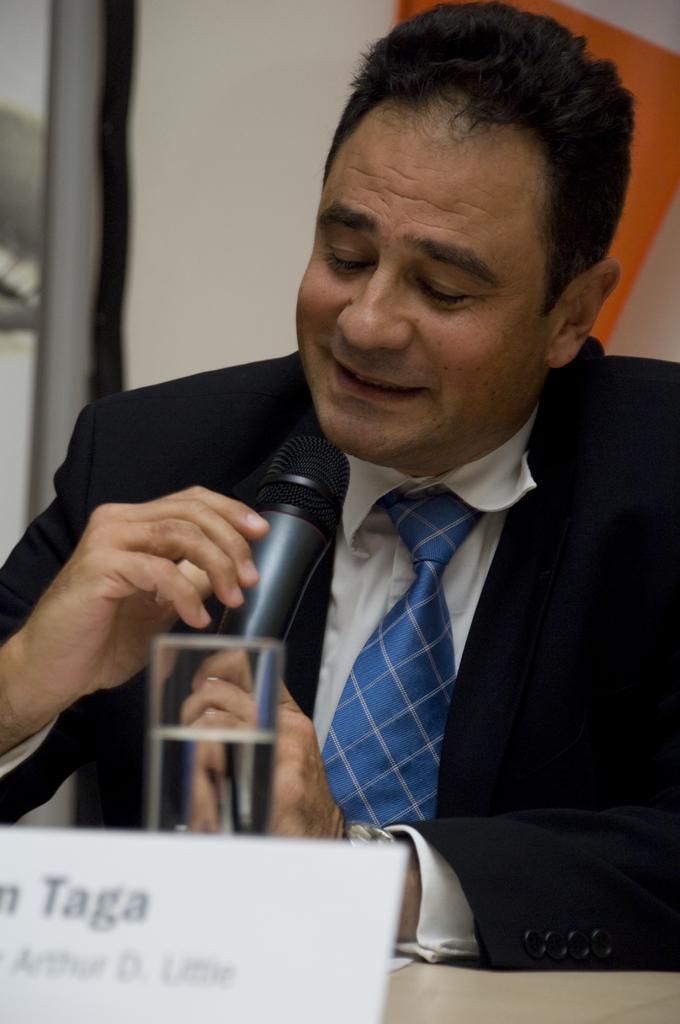Could you give a brief overview of what you see in this image? In this image I can see a man is holding a mic. I can also see a smile on his face. 